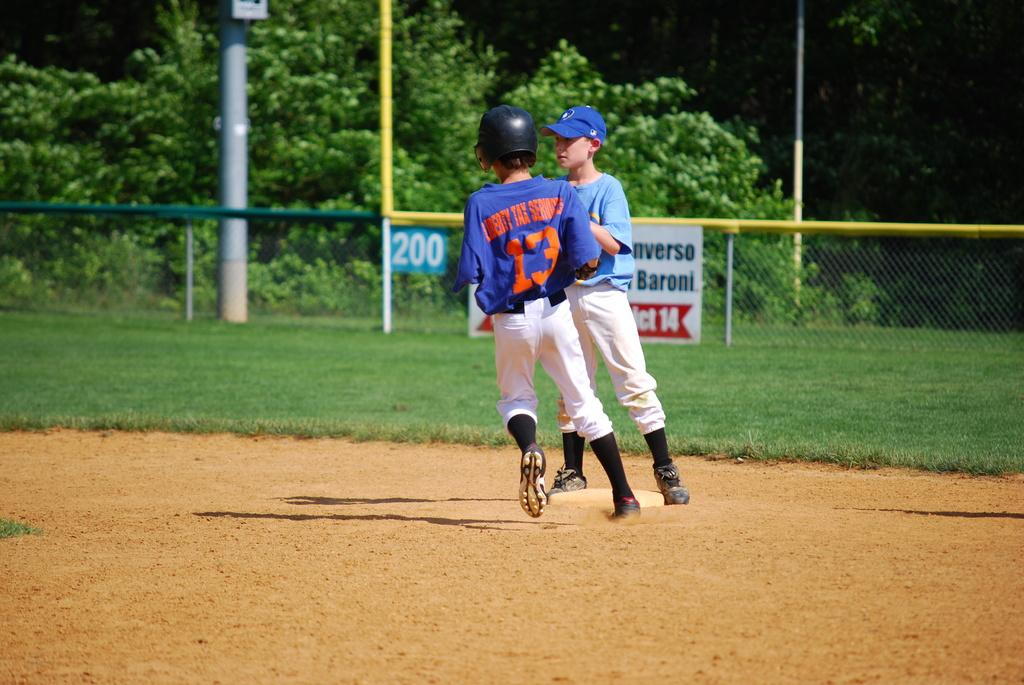<image>
Present a compact description of the photo's key features. Baseball player number 13 in a dark blue shirt runs the bases, while a player in a light blue shirt waits at a base to tag him out. 